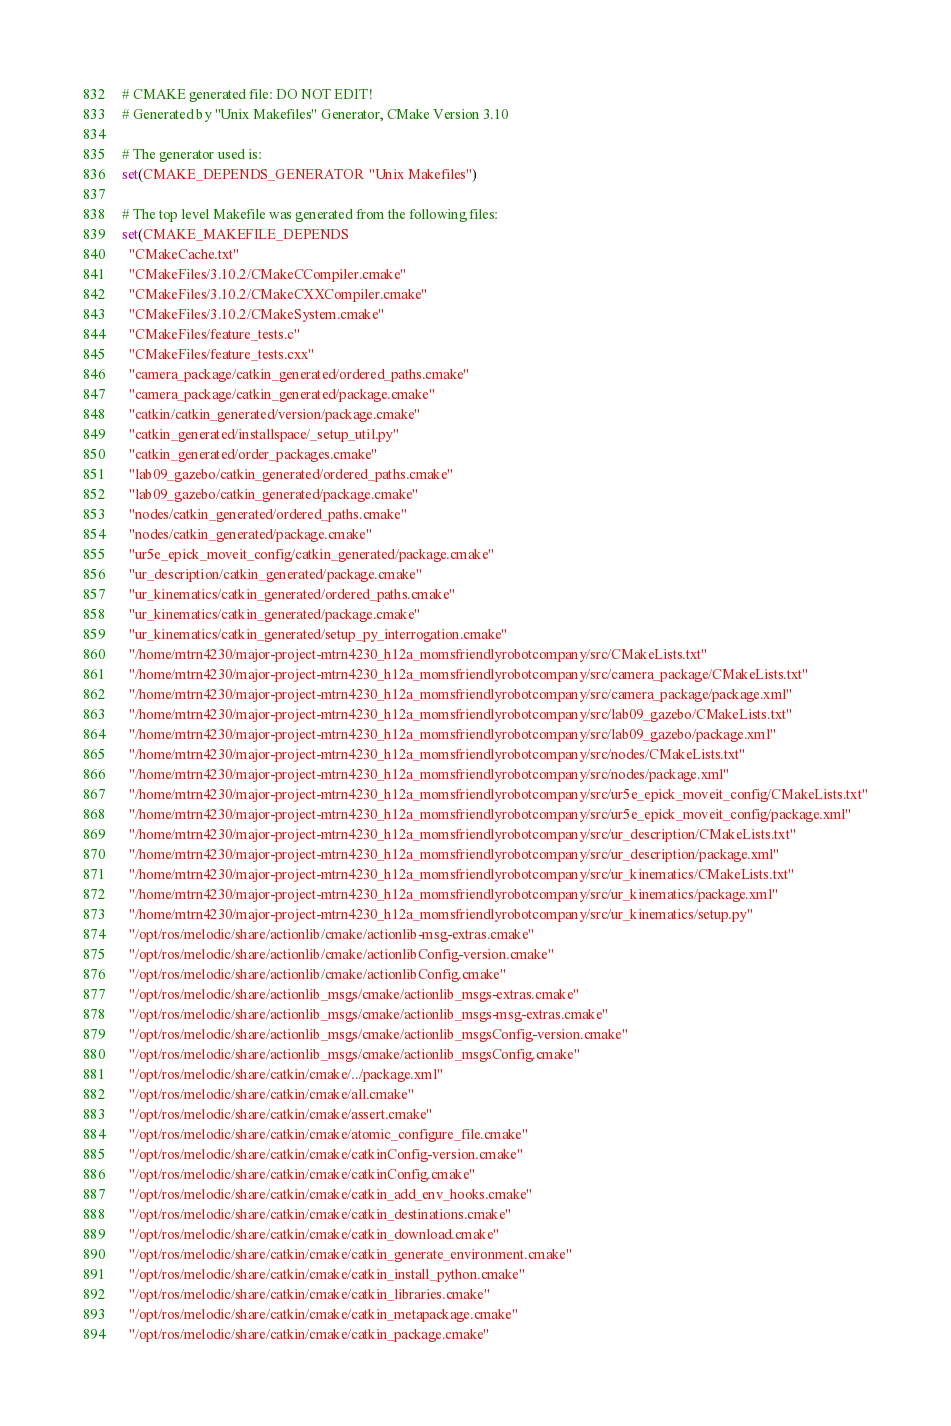<code> <loc_0><loc_0><loc_500><loc_500><_CMake_># CMAKE generated file: DO NOT EDIT!
# Generated by "Unix Makefiles" Generator, CMake Version 3.10

# The generator used is:
set(CMAKE_DEPENDS_GENERATOR "Unix Makefiles")

# The top level Makefile was generated from the following files:
set(CMAKE_MAKEFILE_DEPENDS
  "CMakeCache.txt"
  "CMakeFiles/3.10.2/CMakeCCompiler.cmake"
  "CMakeFiles/3.10.2/CMakeCXXCompiler.cmake"
  "CMakeFiles/3.10.2/CMakeSystem.cmake"
  "CMakeFiles/feature_tests.c"
  "CMakeFiles/feature_tests.cxx"
  "camera_package/catkin_generated/ordered_paths.cmake"
  "camera_package/catkin_generated/package.cmake"
  "catkin/catkin_generated/version/package.cmake"
  "catkin_generated/installspace/_setup_util.py"
  "catkin_generated/order_packages.cmake"
  "lab09_gazebo/catkin_generated/ordered_paths.cmake"
  "lab09_gazebo/catkin_generated/package.cmake"
  "nodes/catkin_generated/ordered_paths.cmake"
  "nodes/catkin_generated/package.cmake"
  "ur5e_epick_moveit_config/catkin_generated/package.cmake"
  "ur_description/catkin_generated/package.cmake"
  "ur_kinematics/catkin_generated/ordered_paths.cmake"
  "ur_kinematics/catkin_generated/package.cmake"
  "ur_kinematics/catkin_generated/setup_py_interrogation.cmake"
  "/home/mtrn4230/major-project-mtrn4230_h12a_momsfriendlyrobotcompany/src/CMakeLists.txt"
  "/home/mtrn4230/major-project-mtrn4230_h12a_momsfriendlyrobotcompany/src/camera_package/CMakeLists.txt"
  "/home/mtrn4230/major-project-mtrn4230_h12a_momsfriendlyrobotcompany/src/camera_package/package.xml"
  "/home/mtrn4230/major-project-mtrn4230_h12a_momsfriendlyrobotcompany/src/lab09_gazebo/CMakeLists.txt"
  "/home/mtrn4230/major-project-mtrn4230_h12a_momsfriendlyrobotcompany/src/lab09_gazebo/package.xml"
  "/home/mtrn4230/major-project-mtrn4230_h12a_momsfriendlyrobotcompany/src/nodes/CMakeLists.txt"
  "/home/mtrn4230/major-project-mtrn4230_h12a_momsfriendlyrobotcompany/src/nodes/package.xml"
  "/home/mtrn4230/major-project-mtrn4230_h12a_momsfriendlyrobotcompany/src/ur5e_epick_moveit_config/CMakeLists.txt"
  "/home/mtrn4230/major-project-mtrn4230_h12a_momsfriendlyrobotcompany/src/ur5e_epick_moveit_config/package.xml"
  "/home/mtrn4230/major-project-mtrn4230_h12a_momsfriendlyrobotcompany/src/ur_description/CMakeLists.txt"
  "/home/mtrn4230/major-project-mtrn4230_h12a_momsfriendlyrobotcompany/src/ur_description/package.xml"
  "/home/mtrn4230/major-project-mtrn4230_h12a_momsfriendlyrobotcompany/src/ur_kinematics/CMakeLists.txt"
  "/home/mtrn4230/major-project-mtrn4230_h12a_momsfriendlyrobotcompany/src/ur_kinematics/package.xml"
  "/home/mtrn4230/major-project-mtrn4230_h12a_momsfriendlyrobotcompany/src/ur_kinematics/setup.py"
  "/opt/ros/melodic/share/actionlib/cmake/actionlib-msg-extras.cmake"
  "/opt/ros/melodic/share/actionlib/cmake/actionlibConfig-version.cmake"
  "/opt/ros/melodic/share/actionlib/cmake/actionlibConfig.cmake"
  "/opt/ros/melodic/share/actionlib_msgs/cmake/actionlib_msgs-extras.cmake"
  "/opt/ros/melodic/share/actionlib_msgs/cmake/actionlib_msgs-msg-extras.cmake"
  "/opt/ros/melodic/share/actionlib_msgs/cmake/actionlib_msgsConfig-version.cmake"
  "/opt/ros/melodic/share/actionlib_msgs/cmake/actionlib_msgsConfig.cmake"
  "/opt/ros/melodic/share/catkin/cmake/../package.xml"
  "/opt/ros/melodic/share/catkin/cmake/all.cmake"
  "/opt/ros/melodic/share/catkin/cmake/assert.cmake"
  "/opt/ros/melodic/share/catkin/cmake/atomic_configure_file.cmake"
  "/opt/ros/melodic/share/catkin/cmake/catkinConfig-version.cmake"
  "/opt/ros/melodic/share/catkin/cmake/catkinConfig.cmake"
  "/opt/ros/melodic/share/catkin/cmake/catkin_add_env_hooks.cmake"
  "/opt/ros/melodic/share/catkin/cmake/catkin_destinations.cmake"
  "/opt/ros/melodic/share/catkin/cmake/catkin_download.cmake"
  "/opt/ros/melodic/share/catkin/cmake/catkin_generate_environment.cmake"
  "/opt/ros/melodic/share/catkin/cmake/catkin_install_python.cmake"
  "/opt/ros/melodic/share/catkin/cmake/catkin_libraries.cmake"
  "/opt/ros/melodic/share/catkin/cmake/catkin_metapackage.cmake"
  "/opt/ros/melodic/share/catkin/cmake/catkin_package.cmake"</code> 